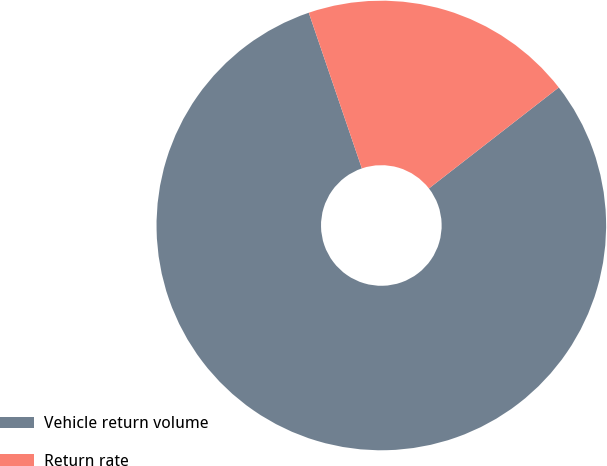Convert chart to OTSL. <chart><loc_0><loc_0><loc_500><loc_500><pie_chart><fcel>Vehicle return volume<fcel>Return rate<nl><fcel>80.29%<fcel>19.71%<nl></chart> 